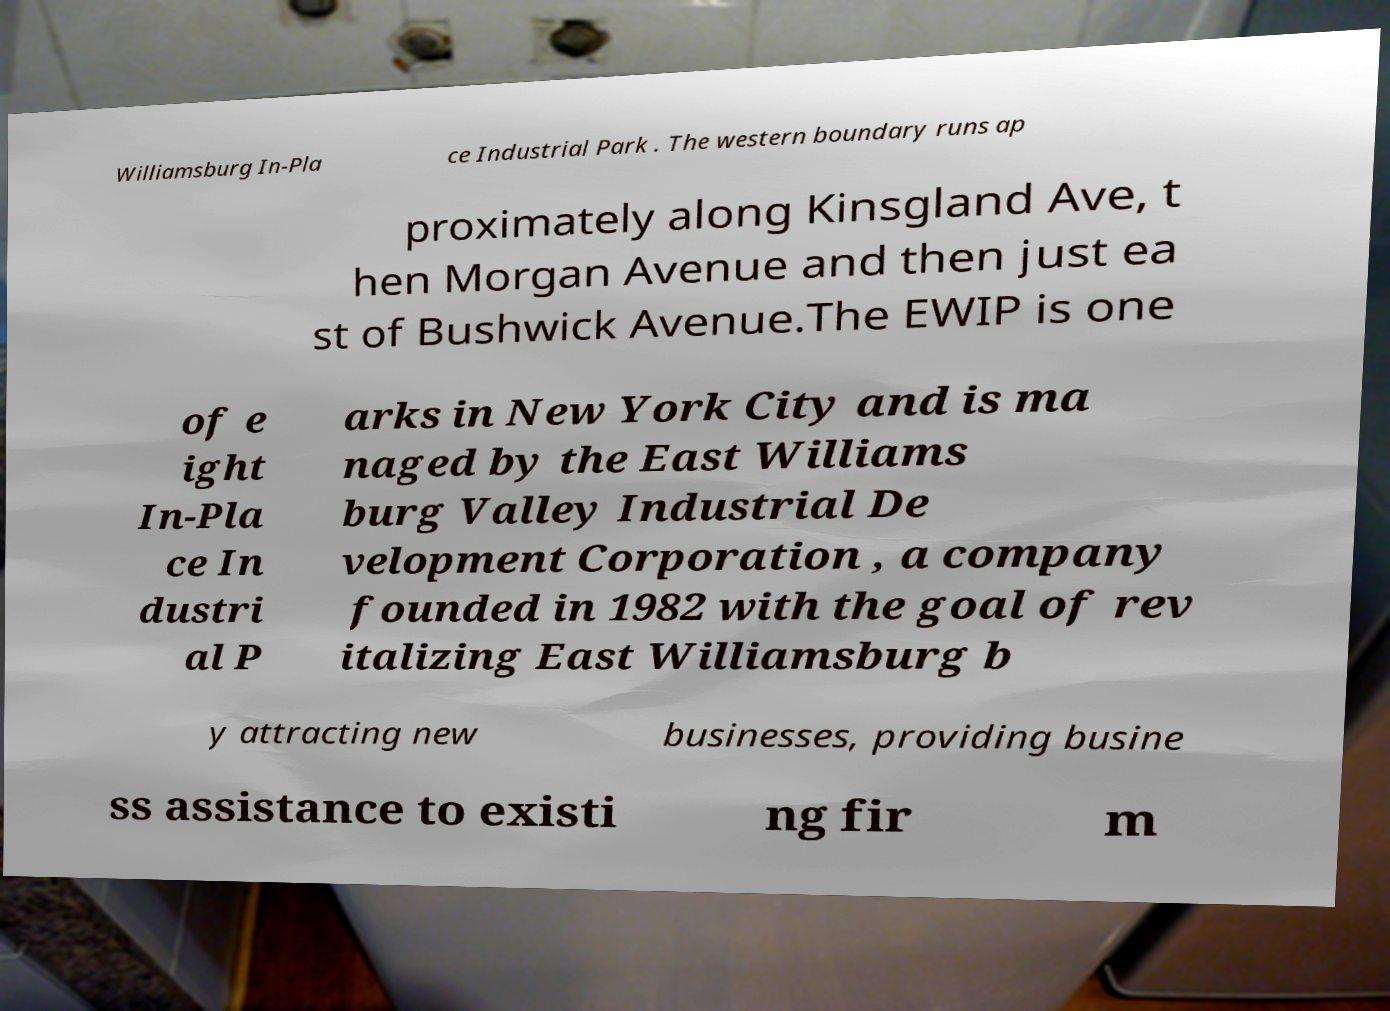Please identify and transcribe the text found in this image. Williamsburg In-Pla ce Industrial Park . The western boundary runs ap proximately along Kinsgland Ave, t hen Morgan Avenue and then just ea st of Bushwick Avenue.The EWIP is one of e ight In-Pla ce In dustri al P arks in New York City and is ma naged by the East Williams burg Valley Industrial De velopment Corporation , a company founded in 1982 with the goal of rev italizing East Williamsburg b y attracting new businesses, providing busine ss assistance to existi ng fir m 